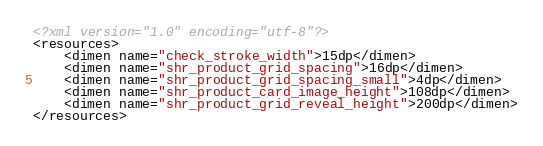<code> <loc_0><loc_0><loc_500><loc_500><_XML_><?xml version="1.0" encoding="utf-8"?>
<resources>
    <dimen name="check_stroke_width">15dp</dimen>
    <dimen name="shr_product_grid_spacing">16dp</dimen>
    <dimen name="shr_product_grid_spacing_small">4dp</dimen>
    <dimen name="shr_product_card_image_height">108dp</dimen>
    <dimen name="shr_product_grid_reveal_height">200dp</dimen>
</resources></code> 